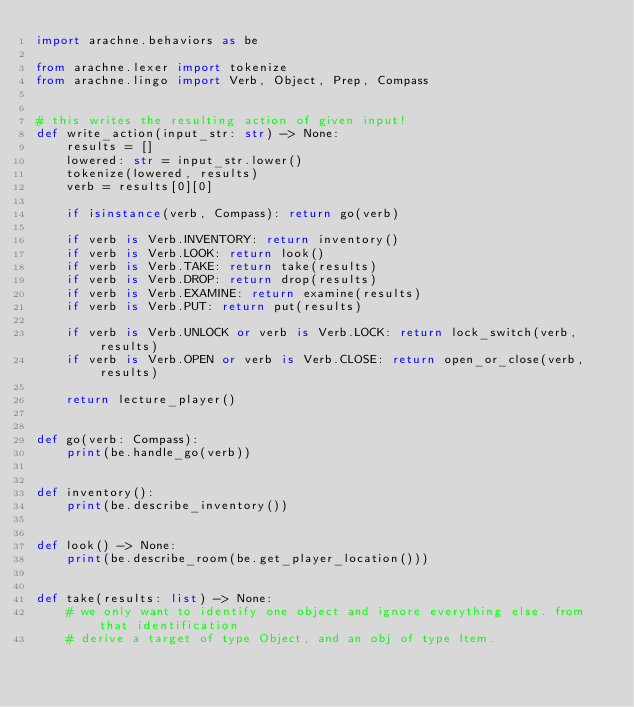<code> <loc_0><loc_0><loc_500><loc_500><_Python_>import arachne.behaviors as be

from arachne.lexer import tokenize
from arachne.lingo import Verb, Object, Prep, Compass


# this writes the resulting action of given input!
def write_action(input_str: str) -> None:
    results = []
    lowered: str = input_str.lower()
    tokenize(lowered, results)
    verb = results[0][0]

    if isinstance(verb, Compass): return go(verb)

    if verb is Verb.INVENTORY: return inventory()
    if verb is Verb.LOOK: return look()
    if verb is Verb.TAKE: return take(results)
    if verb is Verb.DROP: return drop(results)
    if verb is Verb.EXAMINE: return examine(results)
    if verb is Verb.PUT: return put(results)

    if verb is Verb.UNLOCK or verb is Verb.LOCK: return lock_switch(verb, results)
    if verb is Verb.OPEN or verb is Verb.CLOSE: return open_or_close(verb, results)

    return lecture_player()


def go(verb: Compass):
    print(be.handle_go(verb))


def inventory():
    print(be.describe_inventory())


def look() -> None:
    print(be.describe_room(be.get_player_location()))


def take(results: list) -> None:
    # we only want to identify one object and ignore everything else. from that identification
    # derive a target of type Object, and an obj of type Item.</code> 